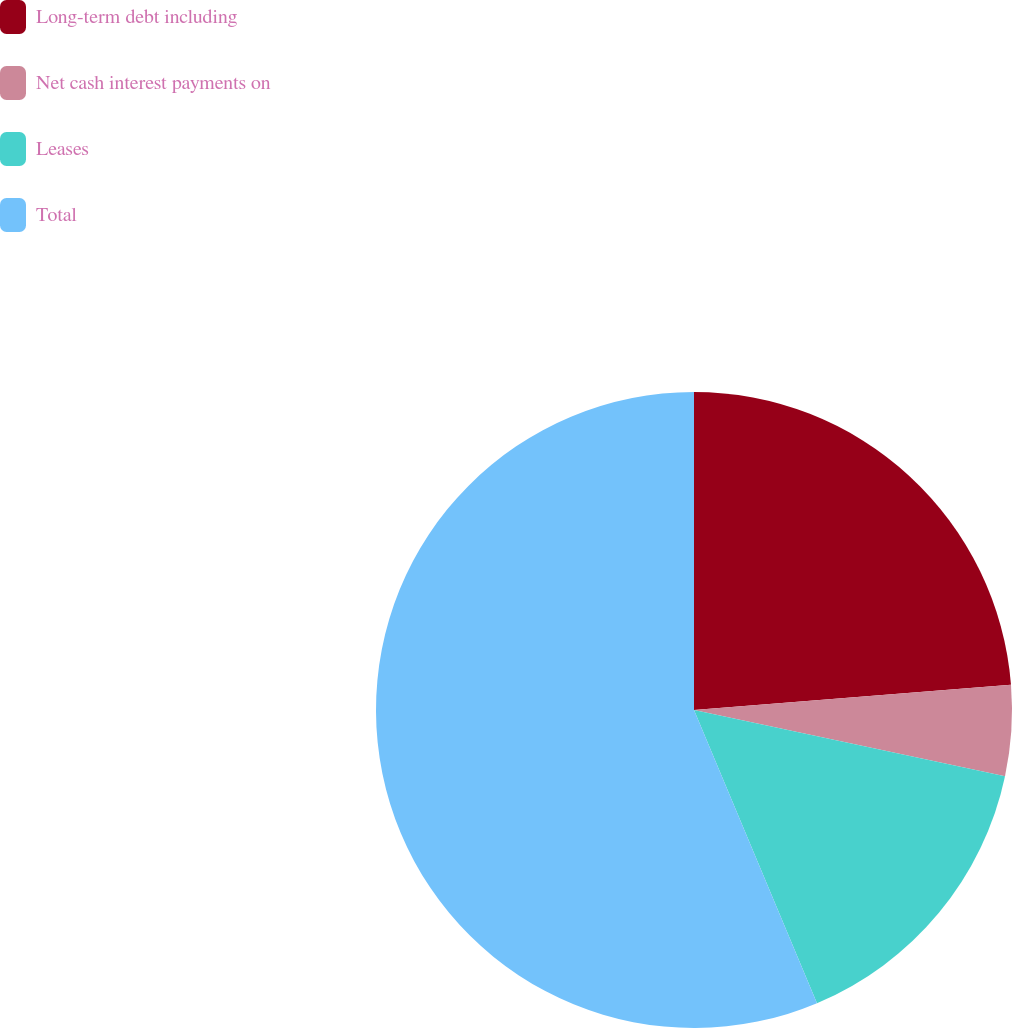<chart> <loc_0><loc_0><loc_500><loc_500><pie_chart><fcel>Long-term debt including<fcel>Net cash interest payments on<fcel>Leases<fcel>Total<nl><fcel>23.74%<fcel>4.6%<fcel>15.34%<fcel>56.32%<nl></chart> 